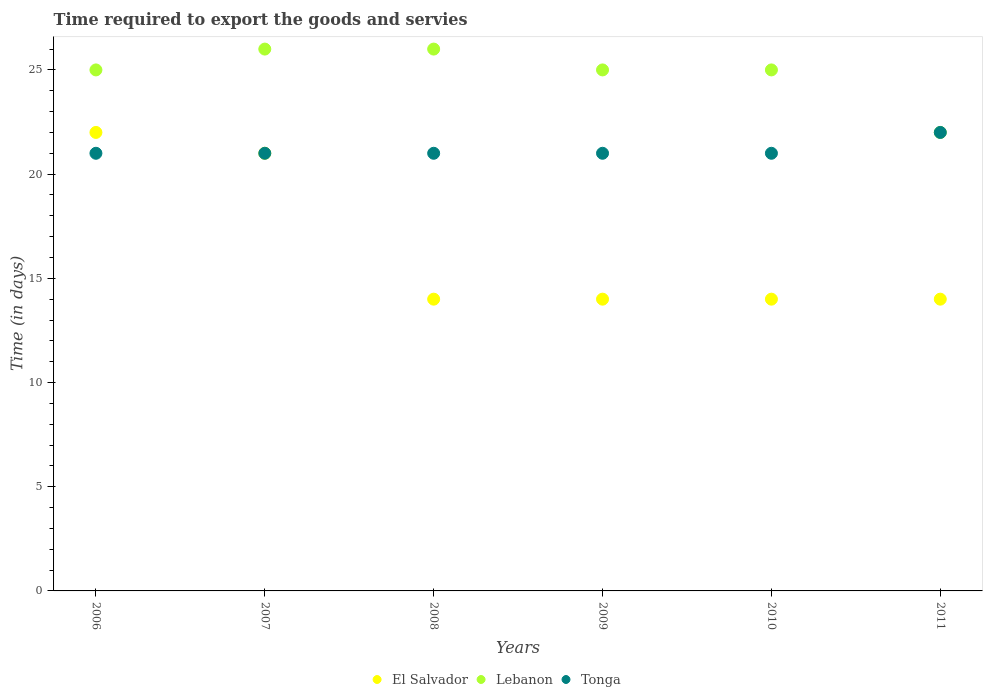Is the number of dotlines equal to the number of legend labels?
Provide a short and direct response. Yes. What is the number of days required to export the goods and services in Tonga in 2011?
Keep it short and to the point. 22. Across all years, what is the maximum number of days required to export the goods and services in Tonga?
Your response must be concise. 22. Across all years, what is the minimum number of days required to export the goods and services in Tonga?
Your response must be concise. 21. In which year was the number of days required to export the goods and services in Lebanon maximum?
Your answer should be compact. 2007. In which year was the number of days required to export the goods and services in Tonga minimum?
Give a very brief answer. 2006. What is the total number of days required to export the goods and services in Lebanon in the graph?
Ensure brevity in your answer.  149. What is the difference between the number of days required to export the goods and services in El Salvador in 2006 and that in 2008?
Offer a very short reply. 8. What is the difference between the number of days required to export the goods and services in Tonga in 2010 and the number of days required to export the goods and services in Lebanon in 2009?
Offer a terse response. -4. What is the average number of days required to export the goods and services in Tonga per year?
Offer a very short reply. 21.17. In the year 2010, what is the difference between the number of days required to export the goods and services in Tonga and number of days required to export the goods and services in El Salvador?
Make the answer very short. 7. In how many years, is the number of days required to export the goods and services in Lebanon greater than 15 days?
Make the answer very short. 6. Is the number of days required to export the goods and services in El Salvador in 2007 less than that in 2008?
Make the answer very short. No. What is the difference between the highest and the second highest number of days required to export the goods and services in Tonga?
Offer a terse response. 1. What is the difference between the highest and the lowest number of days required to export the goods and services in El Salvador?
Your response must be concise. 8. Is the sum of the number of days required to export the goods and services in Lebanon in 2006 and 2007 greater than the maximum number of days required to export the goods and services in Tonga across all years?
Provide a succinct answer. Yes. Is it the case that in every year, the sum of the number of days required to export the goods and services in El Salvador and number of days required to export the goods and services in Lebanon  is greater than the number of days required to export the goods and services in Tonga?
Make the answer very short. Yes. Is the number of days required to export the goods and services in Lebanon strictly greater than the number of days required to export the goods and services in El Salvador over the years?
Make the answer very short. Yes. Is the number of days required to export the goods and services in Tonga strictly less than the number of days required to export the goods and services in El Salvador over the years?
Provide a succinct answer. No. How many dotlines are there?
Your response must be concise. 3. What is the difference between two consecutive major ticks on the Y-axis?
Your answer should be compact. 5. Does the graph contain grids?
Keep it short and to the point. No. Where does the legend appear in the graph?
Provide a short and direct response. Bottom center. What is the title of the graph?
Offer a terse response. Time required to export the goods and servies. Does "Algeria" appear as one of the legend labels in the graph?
Your answer should be compact. No. What is the label or title of the X-axis?
Keep it short and to the point. Years. What is the label or title of the Y-axis?
Provide a succinct answer. Time (in days). What is the Time (in days) of El Salvador in 2007?
Offer a very short reply. 21. What is the Time (in days) of El Salvador in 2008?
Ensure brevity in your answer.  14. What is the Time (in days) in Lebanon in 2008?
Your answer should be very brief. 26. What is the Time (in days) in El Salvador in 2010?
Offer a terse response. 14. What is the Time (in days) of Lebanon in 2010?
Provide a short and direct response. 25. What is the Time (in days) in Tonga in 2010?
Keep it short and to the point. 21. What is the Time (in days) in El Salvador in 2011?
Provide a short and direct response. 14. What is the Time (in days) of Lebanon in 2011?
Keep it short and to the point. 22. What is the Time (in days) of Tonga in 2011?
Your answer should be compact. 22. Across all years, what is the maximum Time (in days) in Tonga?
Make the answer very short. 22. Across all years, what is the minimum Time (in days) in Tonga?
Provide a succinct answer. 21. What is the total Time (in days) of Lebanon in the graph?
Offer a terse response. 149. What is the total Time (in days) in Tonga in the graph?
Ensure brevity in your answer.  127. What is the difference between the Time (in days) in Lebanon in 2006 and that in 2007?
Provide a succinct answer. -1. What is the difference between the Time (in days) in Tonga in 2006 and that in 2007?
Offer a terse response. 0. What is the difference between the Time (in days) of El Salvador in 2006 and that in 2008?
Your response must be concise. 8. What is the difference between the Time (in days) in Lebanon in 2006 and that in 2008?
Offer a terse response. -1. What is the difference between the Time (in days) of Lebanon in 2006 and that in 2009?
Ensure brevity in your answer.  0. What is the difference between the Time (in days) of Tonga in 2006 and that in 2009?
Your response must be concise. 0. What is the difference between the Time (in days) in Lebanon in 2006 and that in 2010?
Offer a very short reply. 0. What is the difference between the Time (in days) of El Salvador in 2007 and that in 2008?
Provide a succinct answer. 7. What is the difference between the Time (in days) of Lebanon in 2007 and that in 2008?
Offer a very short reply. 0. What is the difference between the Time (in days) in Tonga in 2007 and that in 2009?
Your answer should be very brief. 0. What is the difference between the Time (in days) in El Salvador in 2007 and that in 2010?
Offer a very short reply. 7. What is the difference between the Time (in days) in Tonga in 2007 and that in 2010?
Give a very brief answer. 0. What is the difference between the Time (in days) of El Salvador in 2007 and that in 2011?
Your answer should be compact. 7. What is the difference between the Time (in days) of Lebanon in 2007 and that in 2011?
Ensure brevity in your answer.  4. What is the difference between the Time (in days) in Tonga in 2008 and that in 2009?
Provide a succinct answer. 0. What is the difference between the Time (in days) of El Salvador in 2008 and that in 2010?
Your answer should be very brief. 0. What is the difference between the Time (in days) of El Salvador in 2008 and that in 2011?
Make the answer very short. 0. What is the difference between the Time (in days) in Lebanon in 2008 and that in 2011?
Provide a succinct answer. 4. What is the difference between the Time (in days) in Tonga in 2008 and that in 2011?
Your answer should be compact. -1. What is the difference between the Time (in days) in El Salvador in 2009 and that in 2010?
Your answer should be very brief. 0. What is the difference between the Time (in days) in Lebanon in 2009 and that in 2010?
Your response must be concise. 0. What is the difference between the Time (in days) of El Salvador in 2006 and the Time (in days) of Lebanon in 2008?
Give a very brief answer. -4. What is the difference between the Time (in days) of El Salvador in 2006 and the Time (in days) of Tonga in 2008?
Your answer should be very brief. 1. What is the difference between the Time (in days) in El Salvador in 2006 and the Time (in days) in Tonga in 2009?
Offer a terse response. 1. What is the difference between the Time (in days) in El Salvador in 2006 and the Time (in days) in Lebanon in 2010?
Keep it short and to the point. -3. What is the difference between the Time (in days) of El Salvador in 2006 and the Time (in days) of Lebanon in 2011?
Keep it short and to the point. 0. What is the difference between the Time (in days) of Lebanon in 2006 and the Time (in days) of Tonga in 2011?
Your answer should be compact. 3. What is the difference between the Time (in days) of El Salvador in 2007 and the Time (in days) of Tonga in 2008?
Offer a very short reply. 0. What is the difference between the Time (in days) in Lebanon in 2007 and the Time (in days) in Tonga in 2008?
Your response must be concise. 5. What is the difference between the Time (in days) of El Salvador in 2007 and the Time (in days) of Tonga in 2009?
Offer a terse response. 0. What is the difference between the Time (in days) in El Salvador in 2007 and the Time (in days) in Tonga in 2010?
Ensure brevity in your answer.  0. What is the difference between the Time (in days) in El Salvador in 2007 and the Time (in days) in Lebanon in 2011?
Make the answer very short. -1. What is the difference between the Time (in days) in Lebanon in 2007 and the Time (in days) in Tonga in 2011?
Ensure brevity in your answer.  4. What is the difference between the Time (in days) in El Salvador in 2008 and the Time (in days) in Lebanon in 2009?
Your answer should be very brief. -11. What is the difference between the Time (in days) of El Salvador in 2008 and the Time (in days) of Tonga in 2009?
Your response must be concise. -7. What is the difference between the Time (in days) of Lebanon in 2008 and the Time (in days) of Tonga in 2009?
Your response must be concise. 5. What is the difference between the Time (in days) in El Salvador in 2008 and the Time (in days) in Tonga in 2010?
Give a very brief answer. -7. What is the difference between the Time (in days) in El Salvador in 2008 and the Time (in days) in Lebanon in 2011?
Provide a succinct answer. -8. What is the difference between the Time (in days) of El Salvador in 2009 and the Time (in days) of Lebanon in 2010?
Your answer should be compact. -11. What is the difference between the Time (in days) in El Salvador in 2009 and the Time (in days) in Lebanon in 2011?
Make the answer very short. -8. What is the difference between the Time (in days) in El Salvador in 2009 and the Time (in days) in Tonga in 2011?
Provide a succinct answer. -8. What is the difference between the Time (in days) in Lebanon in 2009 and the Time (in days) in Tonga in 2011?
Offer a terse response. 3. What is the average Time (in days) of El Salvador per year?
Keep it short and to the point. 16.5. What is the average Time (in days) of Lebanon per year?
Give a very brief answer. 24.83. What is the average Time (in days) of Tonga per year?
Offer a very short reply. 21.17. In the year 2006, what is the difference between the Time (in days) of Lebanon and Time (in days) of Tonga?
Keep it short and to the point. 4. In the year 2007, what is the difference between the Time (in days) in El Salvador and Time (in days) in Tonga?
Your answer should be compact. 0. In the year 2008, what is the difference between the Time (in days) in El Salvador and Time (in days) in Lebanon?
Your answer should be very brief. -12. In the year 2009, what is the difference between the Time (in days) in El Salvador and Time (in days) in Lebanon?
Your answer should be compact. -11. In the year 2009, what is the difference between the Time (in days) of El Salvador and Time (in days) of Tonga?
Provide a succinct answer. -7. In the year 2009, what is the difference between the Time (in days) of Lebanon and Time (in days) of Tonga?
Keep it short and to the point. 4. In the year 2010, what is the difference between the Time (in days) in El Salvador and Time (in days) in Lebanon?
Offer a very short reply. -11. In the year 2010, what is the difference between the Time (in days) of El Salvador and Time (in days) of Tonga?
Keep it short and to the point. -7. In the year 2011, what is the difference between the Time (in days) of El Salvador and Time (in days) of Lebanon?
Keep it short and to the point. -8. In the year 2011, what is the difference between the Time (in days) in Lebanon and Time (in days) in Tonga?
Ensure brevity in your answer.  0. What is the ratio of the Time (in days) of El Salvador in 2006 to that in 2007?
Ensure brevity in your answer.  1.05. What is the ratio of the Time (in days) of Lebanon in 2006 to that in 2007?
Offer a terse response. 0.96. What is the ratio of the Time (in days) in Tonga in 2006 to that in 2007?
Give a very brief answer. 1. What is the ratio of the Time (in days) in El Salvador in 2006 to that in 2008?
Give a very brief answer. 1.57. What is the ratio of the Time (in days) of Lebanon in 2006 to that in 2008?
Provide a short and direct response. 0.96. What is the ratio of the Time (in days) in El Salvador in 2006 to that in 2009?
Keep it short and to the point. 1.57. What is the ratio of the Time (in days) in Lebanon in 2006 to that in 2009?
Offer a terse response. 1. What is the ratio of the Time (in days) in El Salvador in 2006 to that in 2010?
Provide a short and direct response. 1.57. What is the ratio of the Time (in days) of El Salvador in 2006 to that in 2011?
Offer a very short reply. 1.57. What is the ratio of the Time (in days) of Lebanon in 2006 to that in 2011?
Offer a very short reply. 1.14. What is the ratio of the Time (in days) of Tonga in 2006 to that in 2011?
Your answer should be compact. 0.95. What is the ratio of the Time (in days) in Lebanon in 2007 to that in 2008?
Offer a very short reply. 1. What is the ratio of the Time (in days) of Lebanon in 2007 to that in 2009?
Your response must be concise. 1.04. What is the ratio of the Time (in days) of Tonga in 2007 to that in 2010?
Keep it short and to the point. 1. What is the ratio of the Time (in days) in Lebanon in 2007 to that in 2011?
Provide a short and direct response. 1.18. What is the ratio of the Time (in days) of Tonga in 2007 to that in 2011?
Your answer should be very brief. 0.95. What is the ratio of the Time (in days) of El Salvador in 2008 to that in 2009?
Your response must be concise. 1. What is the ratio of the Time (in days) in Tonga in 2008 to that in 2009?
Keep it short and to the point. 1. What is the ratio of the Time (in days) in El Salvador in 2008 to that in 2011?
Offer a very short reply. 1. What is the ratio of the Time (in days) of Lebanon in 2008 to that in 2011?
Offer a terse response. 1.18. What is the ratio of the Time (in days) of Tonga in 2008 to that in 2011?
Your answer should be very brief. 0.95. What is the ratio of the Time (in days) of El Salvador in 2009 to that in 2011?
Your response must be concise. 1. What is the ratio of the Time (in days) of Lebanon in 2009 to that in 2011?
Provide a short and direct response. 1.14. What is the ratio of the Time (in days) of Tonga in 2009 to that in 2011?
Ensure brevity in your answer.  0.95. What is the ratio of the Time (in days) of Lebanon in 2010 to that in 2011?
Make the answer very short. 1.14. What is the ratio of the Time (in days) of Tonga in 2010 to that in 2011?
Provide a short and direct response. 0.95. What is the difference between the highest and the second highest Time (in days) of El Salvador?
Your answer should be compact. 1. What is the difference between the highest and the second highest Time (in days) in Tonga?
Provide a short and direct response. 1. What is the difference between the highest and the lowest Time (in days) in El Salvador?
Provide a short and direct response. 8. What is the difference between the highest and the lowest Time (in days) of Tonga?
Offer a terse response. 1. 